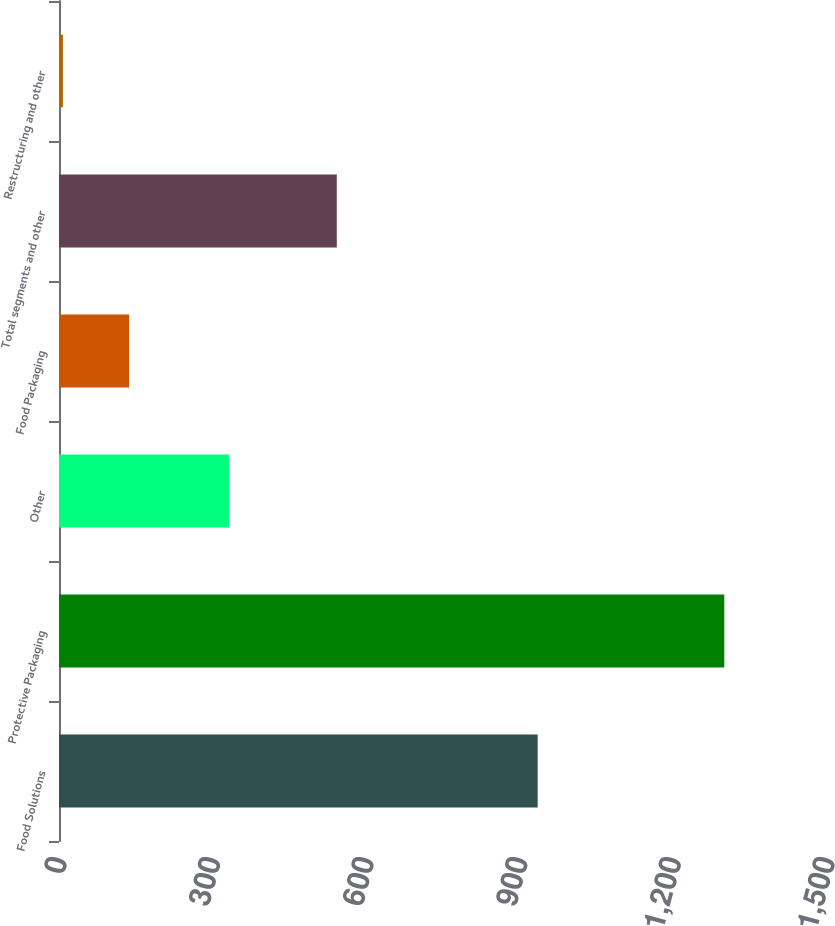Convert chart. <chart><loc_0><loc_0><loc_500><loc_500><bar_chart><fcel>Food Solutions<fcel>Protective Packaging<fcel>Other<fcel>Food Packaging<fcel>Total segments and other<fcel>Restructuring and other<nl><fcel>934.9<fcel>1299.4<fcel>332.2<fcel>136.78<fcel>542.6<fcel>7.6<nl></chart> 